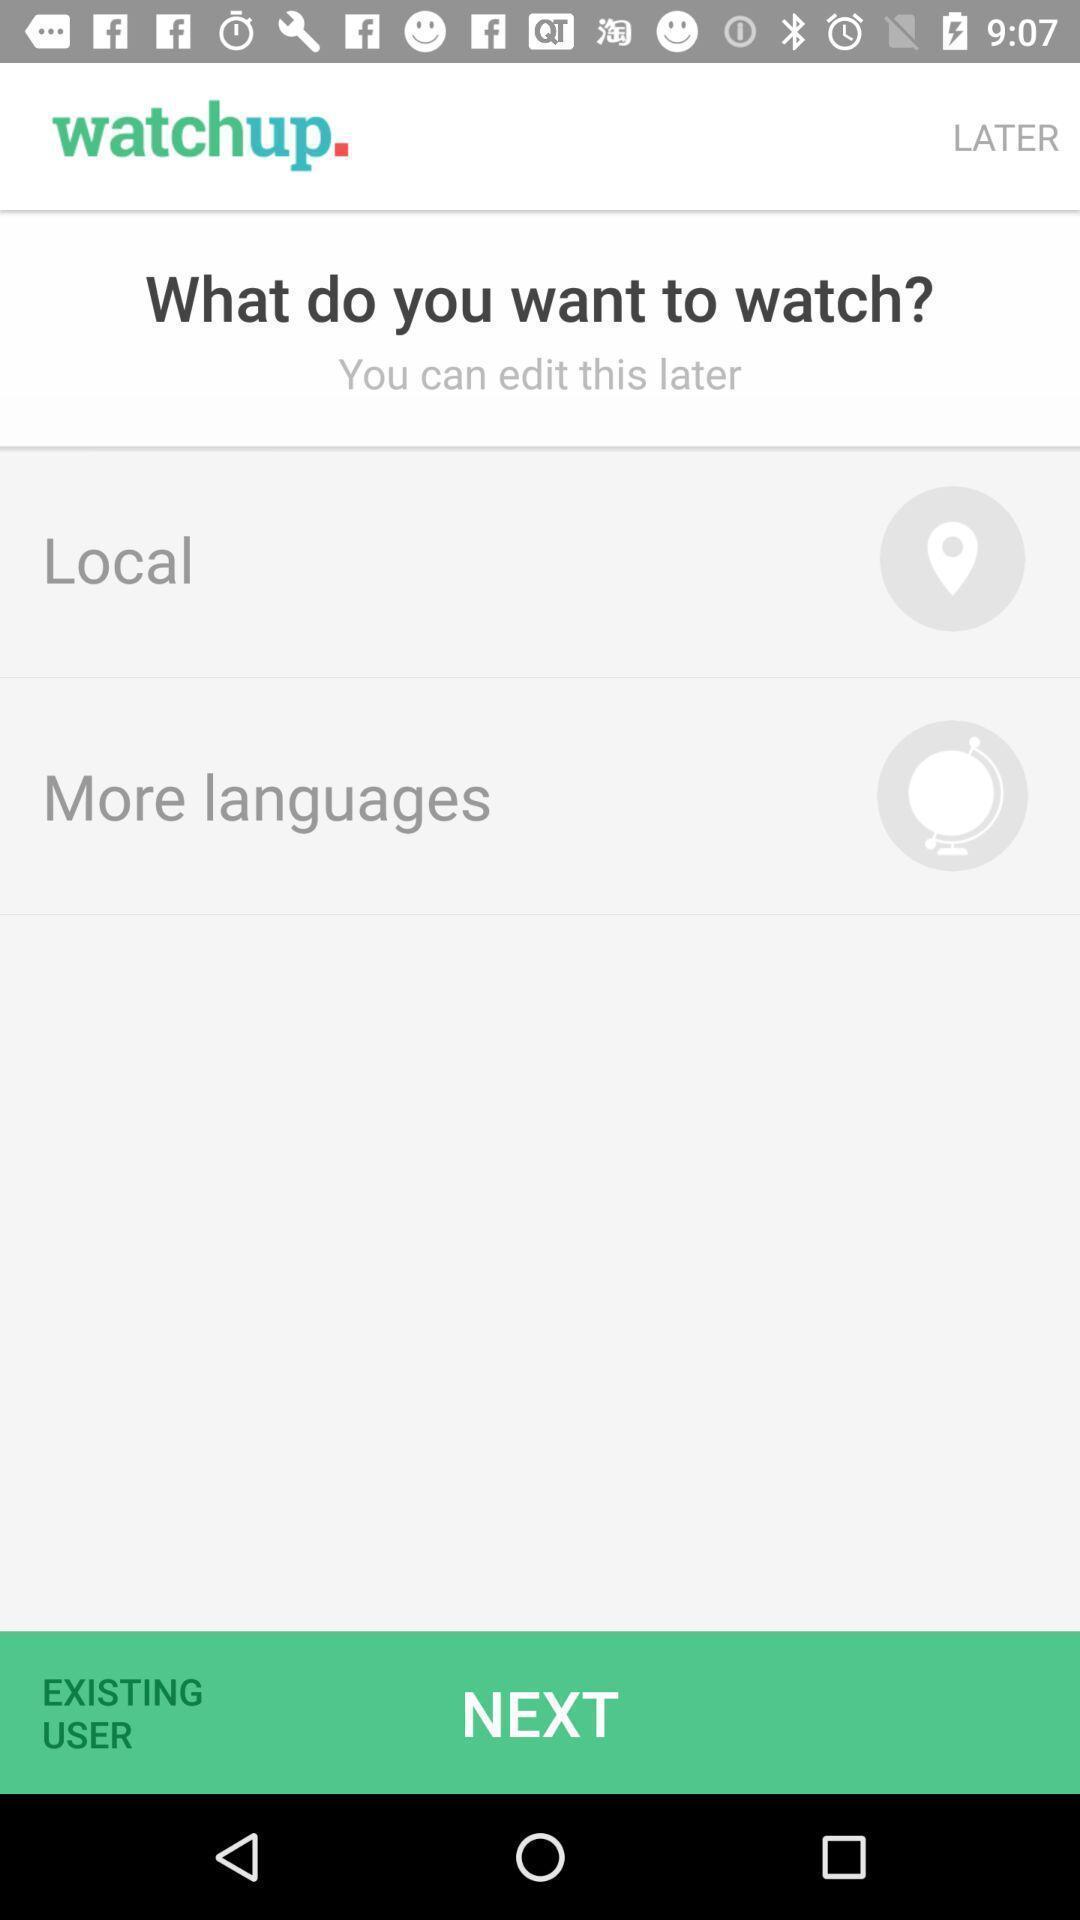Give me a narrative description of this picture. Window displaying with options to choose. 